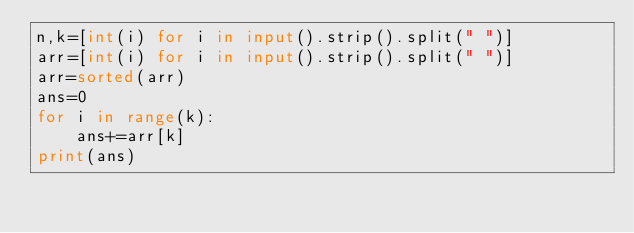Convert code to text. <code><loc_0><loc_0><loc_500><loc_500><_Python_>n,k=[int(i) for i in input().strip().split(" ")]
arr=[int(i) for i in input().strip().split(" ")]
arr=sorted(arr)
ans=0
for i in range(k):
    ans+=arr[k]
print(ans)</code> 